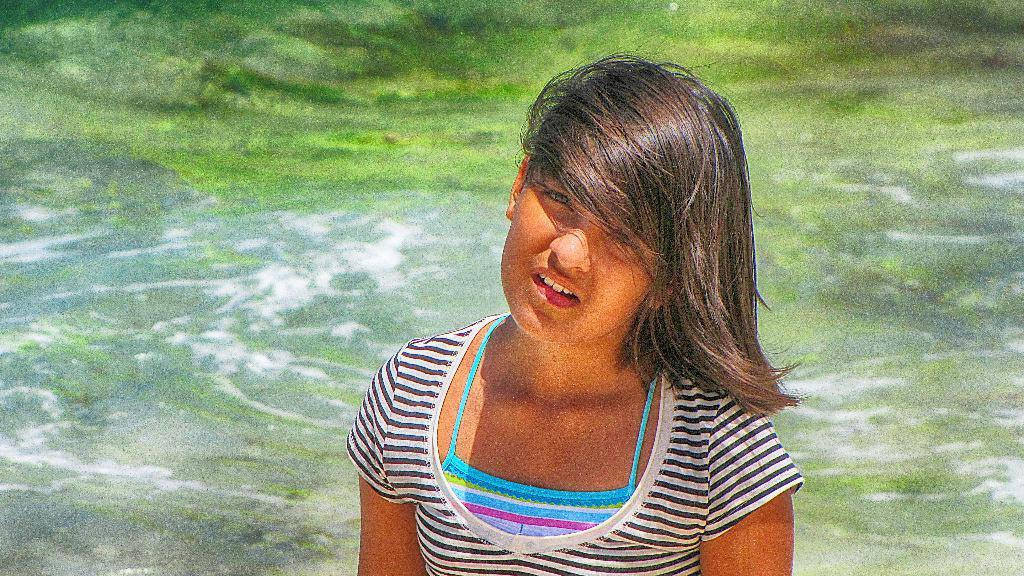Who is the main subject in the image? There is a girl in the image. What natural feature can be seen in the background? The ocean is visible in the image. Can you determine the time of day when the image was taken? The image was likely taken during the day, as there is no indication of darkness or artificial lighting. What type of fowl can be seen flying over the girl in the image? There is no fowl visible in the image; it only features a girl and the ocean in the background. 